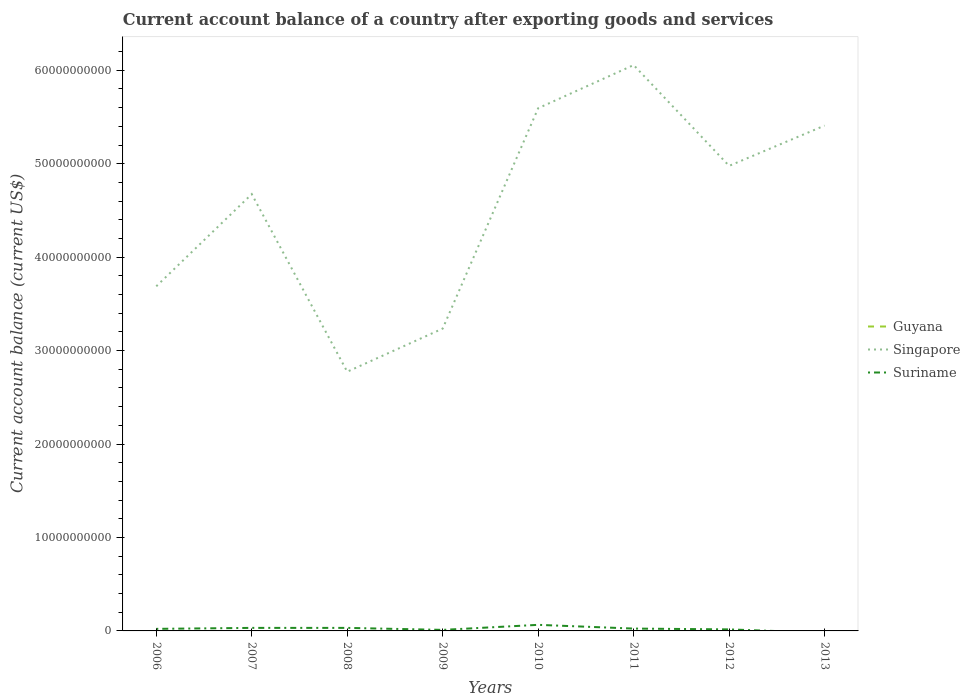Does the line corresponding to Suriname intersect with the line corresponding to Singapore?
Give a very brief answer. No. Is the number of lines equal to the number of legend labels?
Offer a very short reply. No. What is the total account balance in Suriname in the graph?
Your answer should be compact. 5.67e+07. What is the difference between the highest and the second highest account balance in Singapore?
Your response must be concise. 3.28e+1. Is the account balance in Guyana strictly greater than the account balance in Singapore over the years?
Keep it short and to the point. Yes. How many lines are there?
Provide a short and direct response. 2. How many years are there in the graph?
Make the answer very short. 8. Are the values on the major ticks of Y-axis written in scientific E-notation?
Give a very brief answer. No. How are the legend labels stacked?
Offer a very short reply. Vertical. What is the title of the graph?
Offer a terse response. Current account balance of a country after exporting goods and services. Does "Botswana" appear as one of the legend labels in the graph?
Your answer should be very brief. No. What is the label or title of the Y-axis?
Offer a terse response. Current account balance (current US$). What is the Current account balance (current US$) of Singapore in 2006?
Your response must be concise. 3.69e+1. What is the Current account balance (current US$) of Suriname in 2006?
Provide a succinct answer. 2.21e+08. What is the Current account balance (current US$) in Singapore in 2007?
Offer a very short reply. 4.67e+1. What is the Current account balance (current US$) of Suriname in 2007?
Provide a succinct answer. 3.24e+08. What is the Current account balance (current US$) in Singapore in 2008?
Keep it short and to the point. 2.77e+1. What is the Current account balance (current US$) in Suriname in 2008?
Keep it short and to the point. 3.25e+08. What is the Current account balance (current US$) in Guyana in 2009?
Give a very brief answer. 0. What is the Current account balance (current US$) of Singapore in 2009?
Give a very brief answer. 3.24e+1. What is the Current account balance (current US$) in Suriname in 2009?
Offer a very short reply. 1.11e+08. What is the Current account balance (current US$) in Singapore in 2010?
Give a very brief answer. 5.59e+1. What is the Current account balance (current US$) of Suriname in 2010?
Offer a terse response. 6.51e+08. What is the Current account balance (current US$) of Guyana in 2011?
Your answer should be very brief. 0. What is the Current account balance (current US$) in Singapore in 2011?
Provide a short and direct response. 6.06e+1. What is the Current account balance (current US$) of Suriname in 2011?
Provide a short and direct response. 2.51e+08. What is the Current account balance (current US$) of Guyana in 2012?
Make the answer very short. 0. What is the Current account balance (current US$) of Singapore in 2012?
Your answer should be compact. 4.98e+1. What is the Current account balance (current US$) of Suriname in 2012?
Your answer should be very brief. 1.64e+08. What is the Current account balance (current US$) of Guyana in 2013?
Offer a very short reply. 0. What is the Current account balance (current US$) in Singapore in 2013?
Ensure brevity in your answer.  5.41e+1. What is the Current account balance (current US$) in Suriname in 2013?
Your answer should be very brief. 0. Across all years, what is the maximum Current account balance (current US$) of Singapore?
Provide a succinct answer. 6.06e+1. Across all years, what is the maximum Current account balance (current US$) of Suriname?
Offer a terse response. 6.51e+08. Across all years, what is the minimum Current account balance (current US$) in Singapore?
Provide a short and direct response. 2.77e+1. What is the total Current account balance (current US$) in Singapore in the graph?
Offer a very short reply. 3.64e+11. What is the total Current account balance (current US$) in Suriname in the graph?
Your response must be concise. 2.05e+09. What is the difference between the Current account balance (current US$) of Singapore in 2006 and that in 2007?
Provide a short and direct response. -9.86e+09. What is the difference between the Current account balance (current US$) of Suriname in 2006 and that in 2007?
Make the answer very short. -1.04e+08. What is the difference between the Current account balance (current US$) of Singapore in 2006 and that in 2008?
Offer a terse response. 9.14e+09. What is the difference between the Current account balance (current US$) of Suriname in 2006 and that in 2008?
Your answer should be very brief. -1.04e+08. What is the difference between the Current account balance (current US$) in Singapore in 2006 and that in 2009?
Provide a succinct answer. 4.52e+09. What is the difference between the Current account balance (current US$) of Suriname in 2006 and that in 2009?
Keep it short and to the point. 1.09e+08. What is the difference between the Current account balance (current US$) of Singapore in 2006 and that in 2010?
Provide a succinct answer. -1.91e+1. What is the difference between the Current account balance (current US$) of Suriname in 2006 and that in 2010?
Offer a very short reply. -4.30e+08. What is the difference between the Current account balance (current US$) of Singapore in 2006 and that in 2011?
Offer a terse response. -2.37e+1. What is the difference between the Current account balance (current US$) in Suriname in 2006 and that in 2011?
Give a very brief answer. -3.05e+07. What is the difference between the Current account balance (current US$) of Singapore in 2006 and that in 2012?
Offer a terse response. -1.29e+1. What is the difference between the Current account balance (current US$) in Suriname in 2006 and that in 2012?
Ensure brevity in your answer.  5.67e+07. What is the difference between the Current account balance (current US$) of Singapore in 2006 and that in 2013?
Provide a short and direct response. -1.72e+1. What is the difference between the Current account balance (current US$) of Singapore in 2007 and that in 2008?
Your answer should be very brief. 1.90e+1. What is the difference between the Current account balance (current US$) of Singapore in 2007 and that in 2009?
Keep it short and to the point. 1.44e+1. What is the difference between the Current account balance (current US$) of Suriname in 2007 and that in 2009?
Offer a terse response. 2.13e+08. What is the difference between the Current account balance (current US$) in Singapore in 2007 and that in 2010?
Provide a succinct answer. -9.19e+09. What is the difference between the Current account balance (current US$) in Suriname in 2007 and that in 2010?
Make the answer very short. -3.26e+08. What is the difference between the Current account balance (current US$) in Singapore in 2007 and that in 2011?
Your response must be concise. -1.38e+1. What is the difference between the Current account balance (current US$) of Suriname in 2007 and that in 2011?
Ensure brevity in your answer.  7.34e+07. What is the difference between the Current account balance (current US$) of Singapore in 2007 and that in 2012?
Your response must be concise. -3.02e+09. What is the difference between the Current account balance (current US$) in Suriname in 2007 and that in 2012?
Your answer should be compact. 1.61e+08. What is the difference between the Current account balance (current US$) of Singapore in 2007 and that in 2013?
Provide a succinct answer. -7.33e+09. What is the difference between the Current account balance (current US$) in Singapore in 2008 and that in 2009?
Ensure brevity in your answer.  -4.62e+09. What is the difference between the Current account balance (current US$) in Suriname in 2008 and that in 2009?
Make the answer very short. 2.13e+08. What is the difference between the Current account balance (current US$) of Singapore in 2008 and that in 2010?
Offer a terse response. -2.82e+1. What is the difference between the Current account balance (current US$) of Suriname in 2008 and that in 2010?
Provide a succinct answer. -3.26e+08. What is the difference between the Current account balance (current US$) in Singapore in 2008 and that in 2011?
Offer a terse response. -3.28e+1. What is the difference between the Current account balance (current US$) of Suriname in 2008 and that in 2011?
Your answer should be compact. 7.36e+07. What is the difference between the Current account balance (current US$) in Singapore in 2008 and that in 2012?
Give a very brief answer. -2.20e+1. What is the difference between the Current account balance (current US$) in Suriname in 2008 and that in 2012?
Your answer should be compact. 1.61e+08. What is the difference between the Current account balance (current US$) of Singapore in 2008 and that in 2013?
Make the answer very short. -2.63e+1. What is the difference between the Current account balance (current US$) of Singapore in 2009 and that in 2010?
Your response must be concise. -2.36e+1. What is the difference between the Current account balance (current US$) of Suriname in 2009 and that in 2010?
Keep it short and to the point. -5.40e+08. What is the difference between the Current account balance (current US$) of Singapore in 2009 and that in 2011?
Make the answer very short. -2.82e+1. What is the difference between the Current account balance (current US$) in Suriname in 2009 and that in 2011?
Ensure brevity in your answer.  -1.40e+08. What is the difference between the Current account balance (current US$) in Singapore in 2009 and that in 2012?
Your answer should be compact. -1.74e+1. What is the difference between the Current account balance (current US$) in Suriname in 2009 and that in 2012?
Provide a succinct answer. -5.26e+07. What is the difference between the Current account balance (current US$) in Singapore in 2009 and that in 2013?
Keep it short and to the point. -2.17e+1. What is the difference between the Current account balance (current US$) of Singapore in 2010 and that in 2011?
Your response must be concise. -4.62e+09. What is the difference between the Current account balance (current US$) in Suriname in 2010 and that in 2011?
Give a very brief answer. 4.00e+08. What is the difference between the Current account balance (current US$) of Singapore in 2010 and that in 2012?
Ensure brevity in your answer.  6.17e+09. What is the difference between the Current account balance (current US$) of Suriname in 2010 and that in 2012?
Your answer should be compact. 4.87e+08. What is the difference between the Current account balance (current US$) of Singapore in 2010 and that in 2013?
Provide a succinct answer. 1.86e+09. What is the difference between the Current account balance (current US$) of Singapore in 2011 and that in 2012?
Offer a terse response. 1.08e+1. What is the difference between the Current account balance (current US$) in Suriname in 2011 and that in 2012?
Make the answer very short. 8.72e+07. What is the difference between the Current account balance (current US$) of Singapore in 2011 and that in 2013?
Make the answer very short. 6.48e+09. What is the difference between the Current account balance (current US$) in Singapore in 2012 and that in 2013?
Keep it short and to the point. -4.31e+09. What is the difference between the Current account balance (current US$) in Singapore in 2006 and the Current account balance (current US$) in Suriname in 2007?
Offer a terse response. 3.66e+1. What is the difference between the Current account balance (current US$) of Singapore in 2006 and the Current account balance (current US$) of Suriname in 2008?
Keep it short and to the point. 3.66e+1. What is the difference between the Current account balance (current US$) in Singapore in 2006 and the Current account balance (current US$) in Suriname in 2009?
Ensure brevity in your answer.  3.68e+1. What is the difference between the Current account balance (current US$) of Singapore in 2006 and the Current account balance (current US$) of Suriname in 2010?
Provide a short and direct response. 3.62e+1. What is the difference between the Current account balance (current US$) in Singapore in 2006 and the Current account balance (current US$) in Suriname in 2011?
Keep it short and to the point. 3.66e+1. What is the difference between the Current account balance (current US$) of Singapore in 2006 and the Current account balance (current US$) of Suriname in 2012?
Your answer should be compact. 3.67e+1. What is the difference between the Current account balance (current US$) of Singapore in 2007 and the Current account balance (current US$) of Suriname in 2008?
Give a very brief answer. 4.64e+1. What is the difference between the Current account balance (current US$) of Singapore in 2007 and the Current account balance (current US$) of Suriname in 2009?
Give a very brief answer. 4.66e+1. What is the difference between the Current account balance (current US$) in Singapore in 2007 and the Current account balance (current US$) in Suriname in 2010?
Offer a very short reply. 4.61e+1. What is the difference between the Current account balance (current US$) of Singapore in 2007 and the Current account balance (current US$) of Suriname in 2011?
Make the answer very short. 4.65e+1. What is the difference between the Current account balance (current US$) of Singapore in 2007 and the Current account balance (current US$) of Suriname in 2012?
Your answer should be compact. 4.66e+1. What is the difference between the Current account balance (current US$) of Singapore in 2008 and the Current account balance (current US$) of Suriname in 2009?
Offer a very short reply. 2.76e+1. What is the difference between the Current account balance (current US$) in Singapore in 2008 and the Current account balance (current US$) in Suriname in 2010?
Offer a terse response. 2.71e+1. What is the difference between the Current account balance (current US$) of Singapore in 2008 and the Current account balance (current US$) of Suriname in 2011?
Provide a succinct answer. 2.75e+1. What is the difference between the Current account balance (current US$) in Singapore in 2008 and the Current account balance (current US$) in Suriname in 2012?
Offer a terse response. 2.76e+1. What is the difference between the Current account balance (current US$) in Singapore in 2009 and the Current account balance (current US$) in Suriname in 2010?
Your response must be concise. 3.17e+1. What is the difference between the Current account balance (current US$) in Singapore in 2009 and the Current account balance (current US$) in Suriname in 2011?
Your answer should be very brief. 3.21e+1. What is the difference between the Current account balance (current US$) in Singapore in 2009 and the Current account balance (current US$) in Suriname in 2012?
Your answer should be compact. 3.22e+1. What is the difference between the Current account balance (current US$) in Singapore in 2010 and the Current account balance (current US$) in Suriname in 2011?
Offer a very short reply. 5.57e+1. What is the difference between the Current account balance (current US$) in Singapore in 2010 and the Current account balance (current US$) in Suriname in 2012?
Your response must be concise. 5.58e+1. What is the difference between the Current account balance (current US$) in Singapore in 2011 and the Current account balance (current US$) in Suriname in 2012?
Make the answer very short. 6.04e+1. What is the average Current account balance (current US$) in Singapore per year?
Offer a very short reply. 4.55e+1. What is the average Current account balance (current US$) of Suriname per year?
Ensure brevity in your answer.  2.56e+08. In the year 2006, what is the difference between the Current account balance (current US$) in Singapore and Current account balance (current US$) in Suriname?
Your answer should be compact. 3.67e+1. In the year 2007, what is the difference between the Current account balance (current US$) in Singapore and Current account balance (current US$) in Suriname?
Your answer should be very brief. 4.64e+1. In the year 2008, what is the difference between the Current account balance (current US$) in Singapore and Current account balance (current US$) in Suriname?
Ensure brevity in your answer.  2.74e+1. In the year 2009, what is the difference between the Current account balance (current US$) of Singapore and Current account balance (current US$) of Suriname?
Provide a succinct answer. 3.22e+1. In the year 2010, what is the difference between the Current account balance (current US$) in Singapore and Current account balance (current US$) in Suriname?
Offer a very short reply. 5.53e+1. In the year 2011, what is the difference between the Current account balance (current US$) of Singapore and Current account balance (current US$) of Suriname?
Give a very brief answer. 6.03e+1. In the year 2012, what is the difference between the Current account balance (current US$) in Singapore and Current account balance (current US$) in Suriname?
Your response must be concise. 4.96e+1. What is the ratio of the Current account balance (current US$) in Singapore in 2006 to that in 2007?
Ensure brevity in your answer.  0.79. What is the ratio of the Current account balance (current US$) in Suriname in 2006 to that in 2007?
Your answer should be compact. 0.68. What is the ratio of the Current account balance (current US$) in Singapore in 2006 to that in 2008?
Your answer should be very brief. 1.33. What is the ratio of the Current account balance (current US$) in Suriname in 2006 to that in 2008?
Keep it short and to the point. 0.68. What is the ratio of the Current account balance (current US$) in Singapore in 2006 to that in 2009?
Keep it short and to the point. 1.14. What is the ratio of the Current account balance (current US$) in Suriname in 2006 to that in 2009?
Provide a short and direct response. 1.98. What is the ratio of the Current account balance (current US$) of Singapore in 2006 to that in 2010?
Ensure brevity in your answer.  0.66. What is the ratio of the Current account balance (current US$) in Suriname in 2006 to that in 2010?
Offer a very short reply. 0.34. What is the ratio of the Current account balance (current US$) in Singapore in 2006 to that in 2011?
Your answer should be very brief. 0.61. What is the ratio of the Current account balance (current US$) in Suriname in 2006 to that in 2011?
Your answer should be very brief. 0.88. What is the ratio of the Current account balance (current US$) of Singapore in 2006 to that in 2012?
Offer a very short reply. 0.74. What is the ratio of the Current account balance (current US$) in Suriname in 2006 to that in 2012?
Your answer should be compact. 1.35. What is the ratio of the Current account balance (current US$) in Singapore in 2006 to that in 2013?
Provide a succinct answer. 0.68. What is the ratio of the Current account balance (current US$) in Singapore in 2007 to that in 2008?
Make the answer very short. 1.69. What is the ratio of the Current account balance (current US$) in Singapore in 2007 to that in 2009?
Your response must be concise. 1.44. What is the ratio of the Current account balance (current US$) of Suriname in 2007 to that in 2009?
Provide a succinct answer. 2.92. What is the ratio of the Current account balance (current US$) of Singapore in 2007 to that in 2010?
Your answer should be compact. 0.84. What is the ratio of the Current account balance (current US$) in Suriname in 2007 to that in 2010?
Make the answer very short. 0.5. What is the ratio of the Current account balance (current US$) in Singapore in 2007 to that in 2011?
Keep it short and to the point. 0.77. What is the ratio of the Current account balance (current US$) in Suriname in 2007 to that in 2011?
Keep it short and to the point. 1.29. What is the ratio of the Current account balance (current US$) in Singapore in 2007 to that in 2012?
Your answer should be very brief. 0.94. What is the ratio of the Current account balance (current US$) in Suriname in 2007 to that in 2012?
Provide a succinct answer. 1.98. What is the ratio of the Current account balance (current US$) in Singapore in 2007 to that in 2013?
Ensure brevity in your answer.  0.86. What is the ratio of the Current account balance (current US$) of Singapore in 2008 to that in 2009?
Keep it short and to the point. 0.86. What is the ratio of the Current account balance (current US$) in Suriname in 2008 to that in 2009?
Your answer should be very brief. 2.92. What is the ratio of the Current account balance (current US$) in Singapore in 2008 to that in 2010?
Keep it short and to the point. 0.5. What is the ratio of the Current account balance (current US$) of Suriname in 2008 to that in 2010?
Your response must be concise. 0.5. What is the ratio of the Current account balance (current US$) of Singapore in 2008 to that in 2011?
Give a very brief answer. 0.46. What is the ratio of the Current account balance (current US$) of Suriname in 2008 to that in 2011?
Offer a very short reply. 1.29. What is the ratio of the Current account balance (current US$) of Singapore in 2008 to that in 2012?
Provide a short and direct response. 0.56. What is the ratio of the Current account balance (current US$) of Suriname in 2008 to that in 2012?
Make the answer very short. 1.98. What is the ratio of the Current account balance (current US$) in Singapore in 2008 to that in 2013?
Give a very brief answer. 0.51. What is the ratio of the Current account balance (current US$) in Singapore in 2009 to that in 2010?
Give a very brief answer. 0.58. What is the ratio of the Current account balance (current US$) of Suriname in 2009 to that in 2010?
Offer a very short reply. 0.17. What is the ratio of the Current account balance (current US$) in Singapore in 2009 to that in 2011?
Provide a succinct answer. 0.53. What is the ratio of the Current account balance (current US$) of Suriname in 2009 to that in 2011?
Make the answer very short. 0.44. What is the ratio of the Current account balance (current US$) of Singapore in 2009 to that in 2012?
Your answer should be compact. 0.65. What is the ratio of the Current account balance (current US$) in Suriname in 2009 to that in 2012?
Offer a very short reply. 0.68. What is the ratio of the Current account balance (current US$) of Singapore in 2009 to that in 2013?
Your answer should be compact. 0.6. What is the ratio of the Current account balance (current US$) in Singapore in 2010 to that in 2011?
Keep it short and to the point. 0.92. What is the ratio of the Current account balance (current US$) in Suriname in 2010 to that in 2011?
Keep it short and to the point. 2.59. What is the ratio of the Current account balance (current US$) of Singapore in 2010 to that in 2012?
Your answer should be compact. 1.12. What is the ratio of the Current account balance (current US$) in Suriname in 2010 to that in 2012?
Ensure brevity in your answer.  3.97. What is the ratio of the Current account balance (current US$) of Singapore in 2010 to that in 2013?
Offer a very short reply. 1.03. What is the ratio of the Current account balance (current US$) in Singapore in 2011 to that in 2012?
Provide a succinct answer. 1.22. What is the ratio of the Current account balance (current US$) in Suriname in 2011 to that in 2012?
Provide a succinct answer. 1.53. What is the ratio of the Current account balance (current US$) in Singapore in 2011 to that in 2013?
Give a very brief answer. 1.12. What is the ratio of the Current account balance (current US$) in Singapore in 2012 to that in 2013?
Give a very brief answer. 0.92. What is the difference between the highest and the second highest Current account balance (current US$) in Singapore?
Your response must be concise. 4.62e+09. What is the difference between the highest and the second highest Current account balance (current US$) in Suriname?
Keep it short and to the point. 3.26e+08. What is the difference between the highest and the lowest Current account balance (current US$) of Singapore?
Offer a very short reply. 3.28e+1. What is the difference between the highest and the lowest Current account balance (current US$) in Suriname?
Your answer should be very brief. 6.51e+08. 